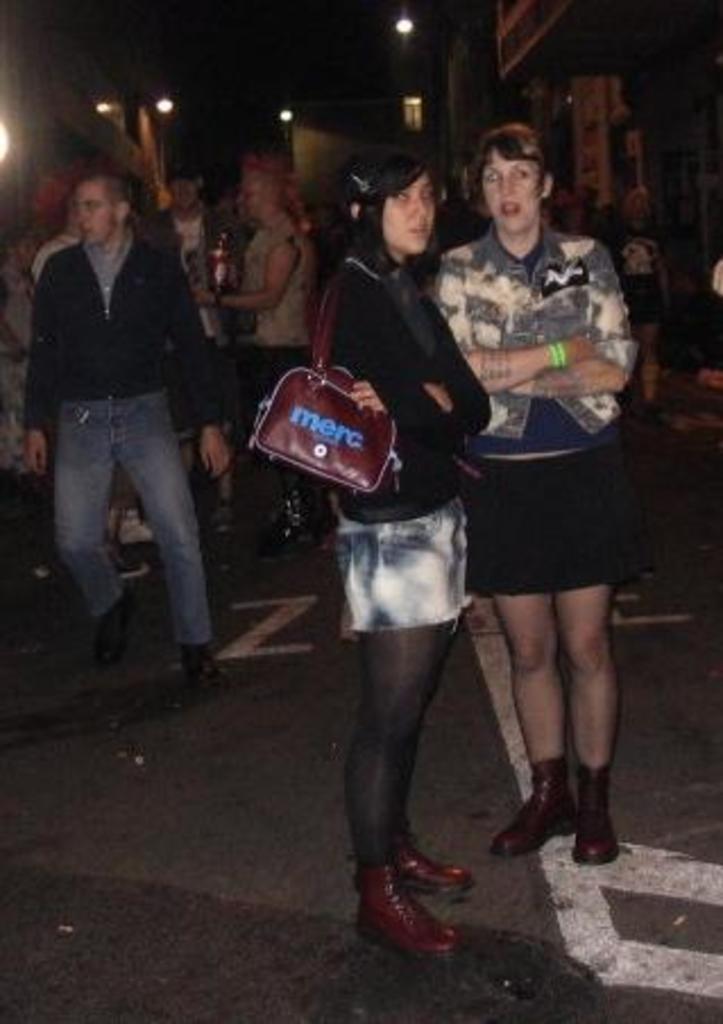Could you give a brief overview of what you see in this image? In this image, I can see few people standing on the road. In the background, there are buildings and lights. 